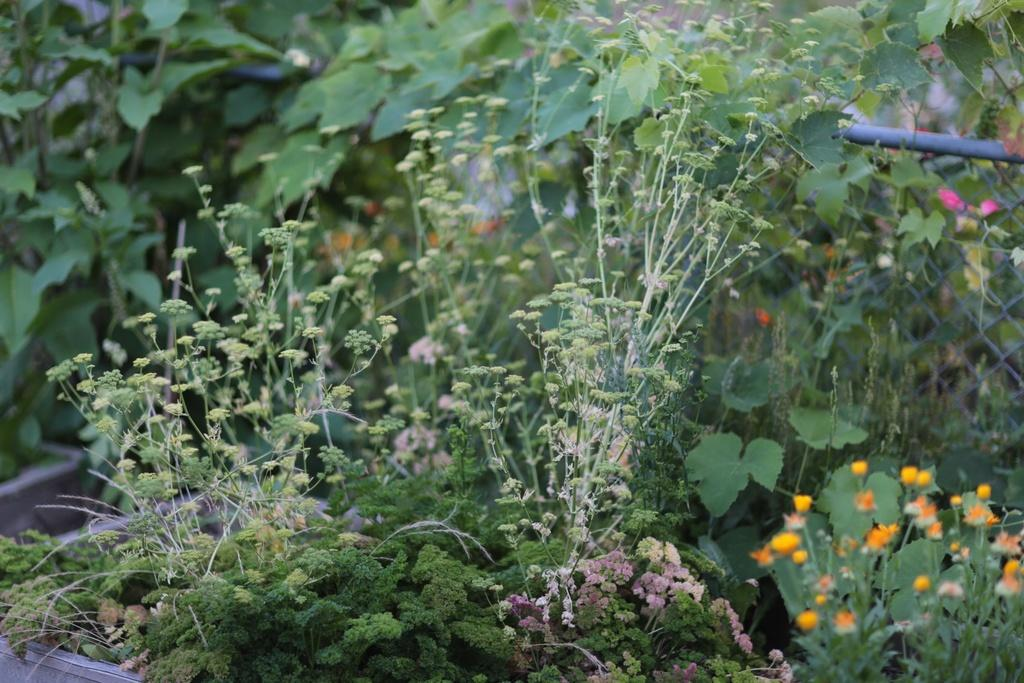What type of plant is visible in the image? There are flowers on a plant in the image. Can you describe the setting in which the plant is located? The plant is in a pot, and there are multiple plants in pots in the background of the image. What type of joke is being told by the shoe in the image? There is no shoe present in the image, and therefore no joke being told. 